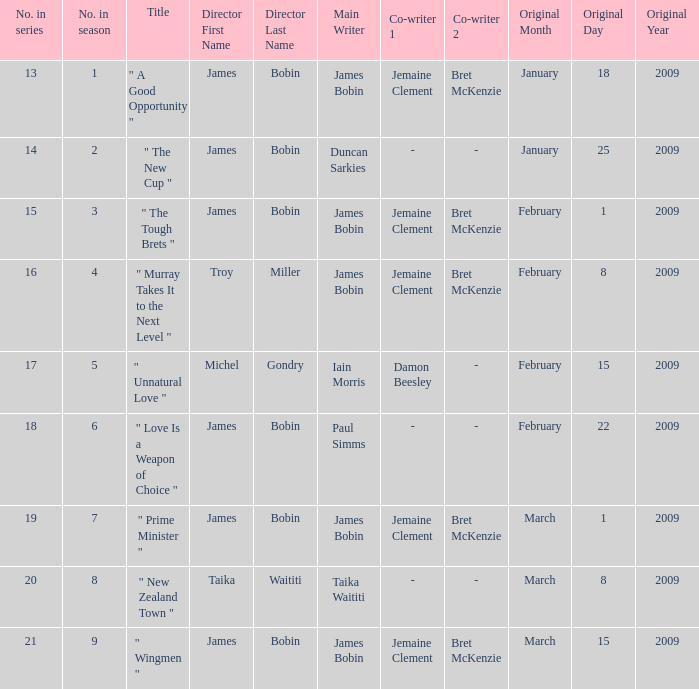 what's the original air date where written by is iain morris & damon beesley February15,2009. 